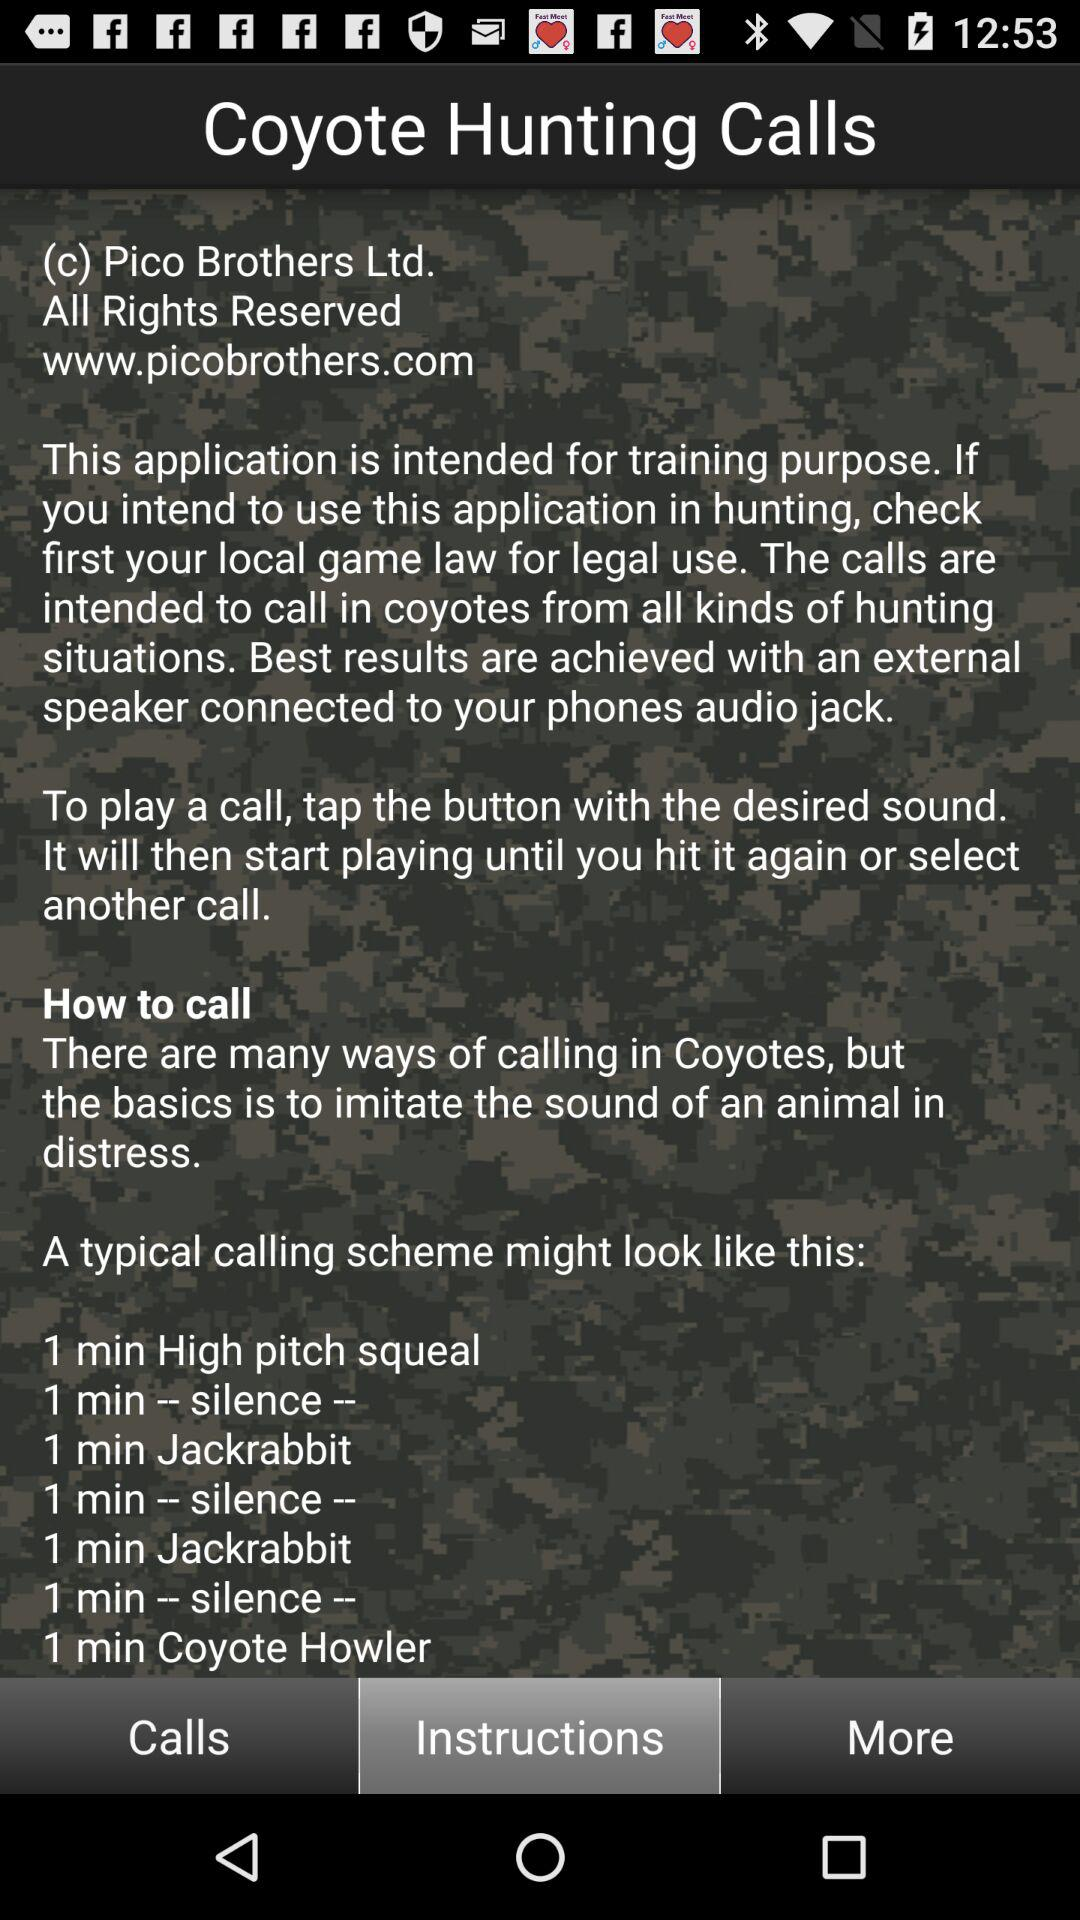How many times does the text "silence" appear in the instructions? 3 